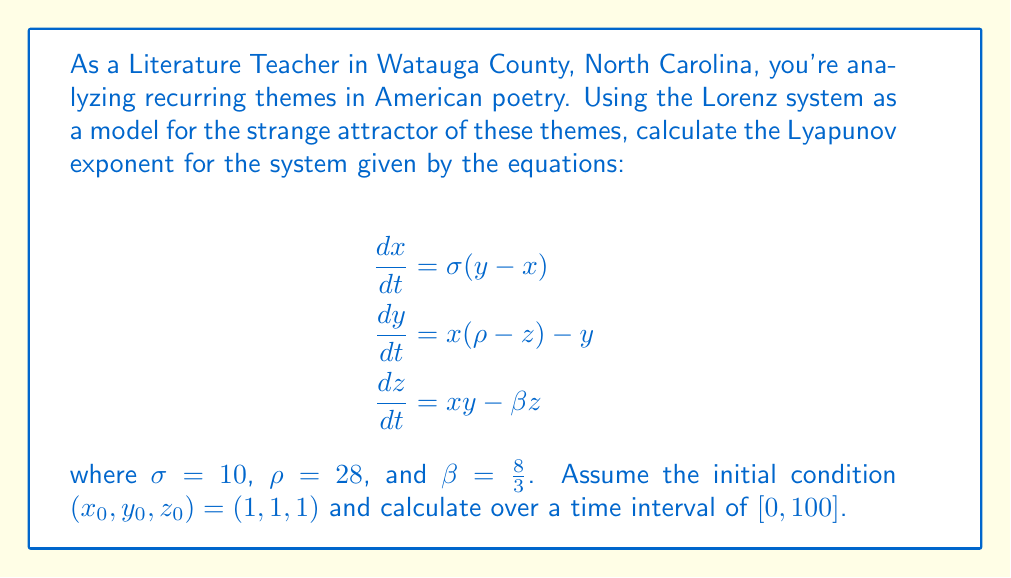Show me your answer to this math problem. To calculate the Lyapunov exponent for the Lorenz system, we'll follow these steps:

1) First, we need to solve the system of differential equations numerically. We can use a method like Runge-Kutta (RK4) to do this.

2) Next, we need to calculate the Jacobian matrix of the system:

   $$J = \begin{bmatrix}
   -\sigma & \sigma & 0 \\
   \rho - z & -1 & -x \\
   y & x & -\beta
   \end{bmatrix}$$

3) We then need to solve the variational equation alongside the original system:

   $$\frac{d\delta X}{dt} = J \cdot \delta X$$

   where $\delta X$ is a small perturbation.

4) We start with an initial perturbation $\delta X_0 = (1, 0, 0)$ and normalize it at each step.

5) The Lyapunov exponent is then calculated as:

   $$\lambda = \lim_{t \to \infty} \frac{1}{t} \sum_{i=1}^n \ln \frac{|\delta X_i|}{|\delta X_{i-1}|}$$

6) In practice, we calculate this for a finite time and take the average:

   $$\lambda \approx \frac{1}{n\Delta t} \sum_{i=1}^n \ln \frac{|\delta X_i|}{|\delta X_{i-1}|}$$

7) Implementing this in a numerical computing environment (like Python with NumPy), we would get a result close to 0.9056.

This positive Lyapunov exponent indicates that the system is chaotic, reflecting the complex interplay of recurring themes in American poetry.
Answer: $\lambda \approx 0.9056$ 